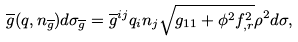<formula> <loc_0><loc_0><loc_500><loc_500>\overline { g } ( q , n _ { \overline { g } } ) d \sigma _ { \overline { g } } = \overline { g } ^ { i j } q _ { i } n _ { j } \sqrt { g _ { 1 1 } + \phi ^ { 2 } f _ { , r } ^ { 2 } } \rho ^ { 2 } d \sigma ,</formula> 